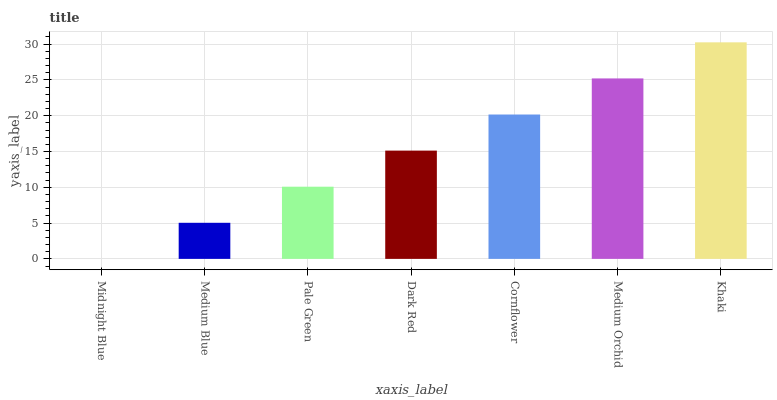Is Medium Blue the minimum?
Answer yes or no. No. Is Medium Blue the maximum?
Answer yes or no. No. Is Medium Blue greater than Midnight Blue?
Answer yes or no. Yes. Is Midnight Blue less than Medium Blue?
Answer yes or no. Yes. Is Midnight Blue greater than Medium Blue?
Answer yes or no. No. Is Medium Blue less than Midnight Blue?
Answer yes or no. No. Is Dark Red the high median?
Answer yes or no. Yes. Is Dark Red the low median?
Answer yes or no. Yes. Is Medium Orchid the high median?
Answer yes or no. No. Is Medium Blue the low median?
Answer yes or no. No. 